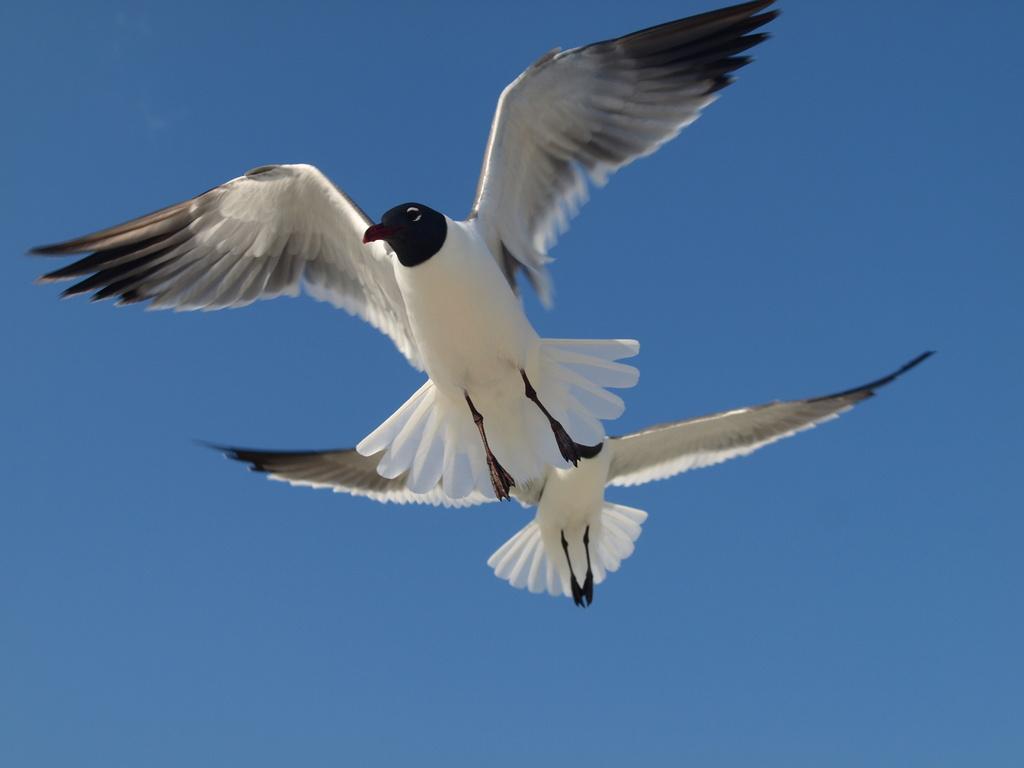In one or two sentences, can you explain what this image depicts? In this image I can see two white color birds flying in the air. In the background, I can see the sky in blue color. 